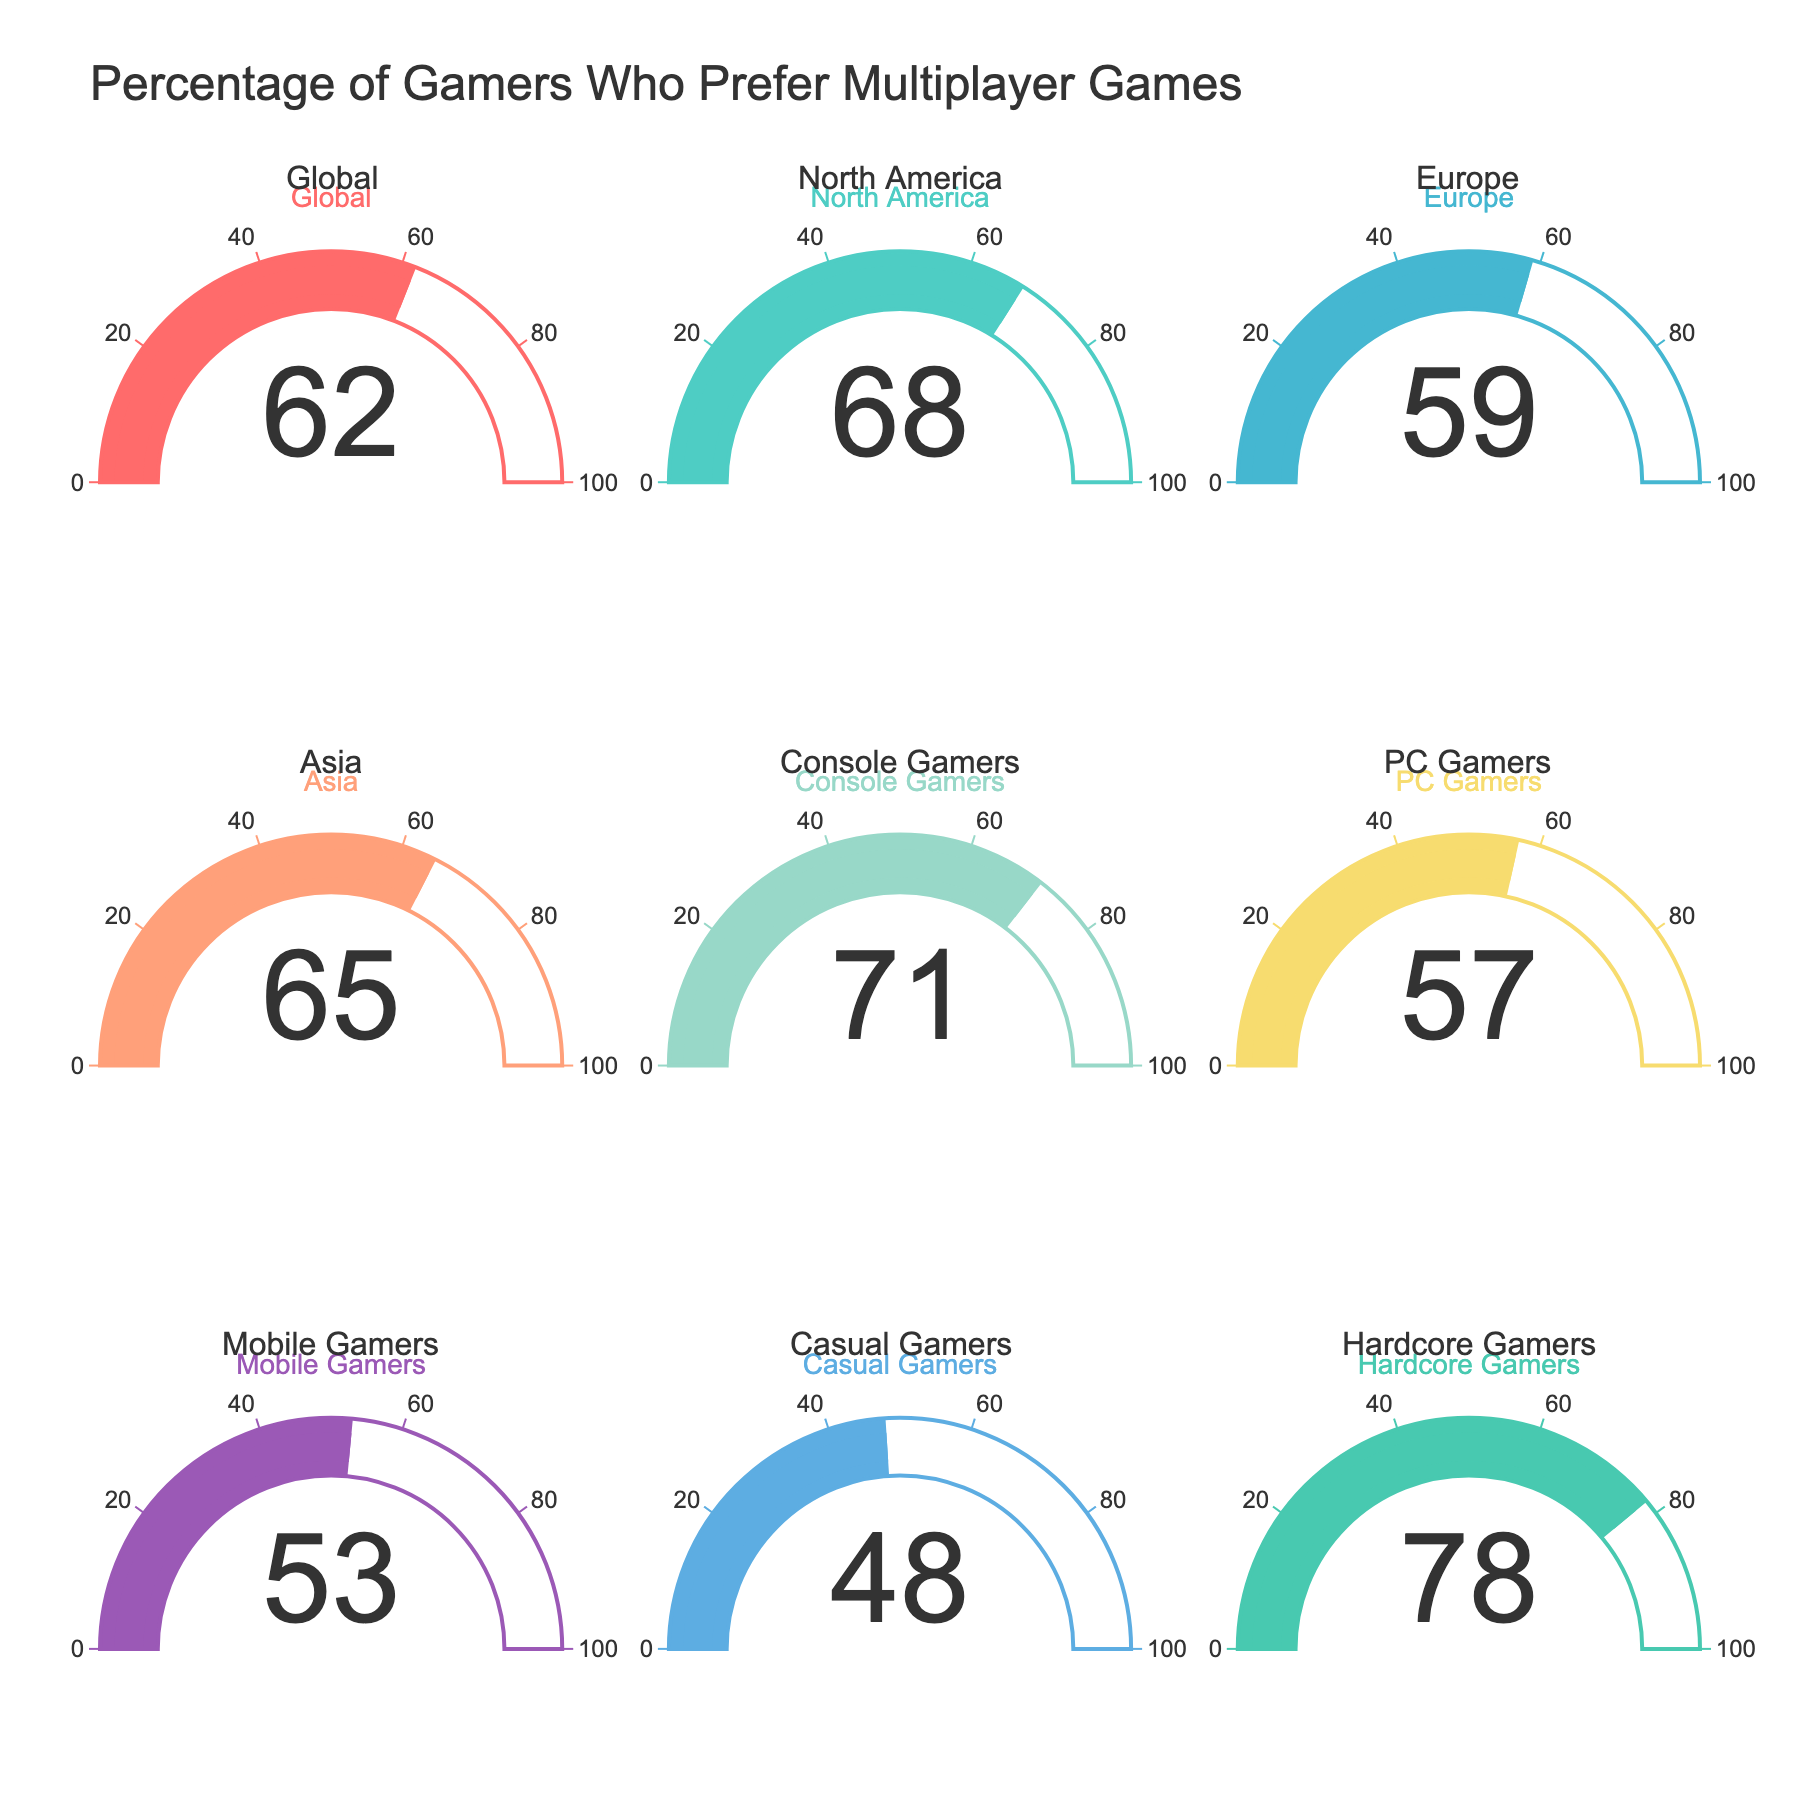What is the highest percentage of gamers who prefer multiplayer games? By scanning through all the gauges, the highest percentage present is among Hardcore Gamers with a value of 78%.
Answer: 78% Which group has the lowest preference for multiplayer games? By examining all the gauges, Mobile Gamers have the lowest percentage with a value of 53%.
Answer: Mobile Gamers Who prefers multiplayer games more, Console Gamers or PC Gamers? Console Gamers have a percentage of 71%, whereas PC Gamers have 57%. So, Console Gamers prefer multiplayer games more.
Answer: Console Gamers What is the average percentage preference for multiplayer games among Global, North America, and Europe? The percentages for Global, North America, and Europe are 62%, 68%, and 59%, respectively. Average = (62 + 68 + 59) / 3 = 63%.
Answer: 63% Which region has a higher preference for multiplayer games, Asia or Europe? The gauge for Asia shows 65%, while Europe shows 59%. Asia has a higher preference.
Answer: Asia What is the difference in multiplayer game preference between Casual Gamers and Hardcore Gamers? Hardcore Gamers have a preference of 78%, and Casual Gamers have 48%. Difference = 78 - 48 = 30%.
Answer: 30% Is the preference for multiplayer games among Mobile Gamers higher than the Global average? The Global average is 62% and Mobile Gamers have 53%. 53% is less than 62%.
Answer: No What is the total percentage sum of preferences for multiplayer games among Console, PC, and Mobile Gamers? The percentages are 71% (Console), 57% (PC), and 53% (Mobile). Sum = 71 + 57 + 53 = 181%.
Answer: 181% Do Casual Gamers have a preference for multiplayer games below or above 50%? The gauge shows that Casual Gamers have a 48% preference, which is below 50%.
Answer: Below 50% Among the regions shown (Global, North America, Europe, Asia), which one has the second-highest preference for multiplayer games? North America has the highest at 68%. Asia is next at 65%.
Answer: Asia 